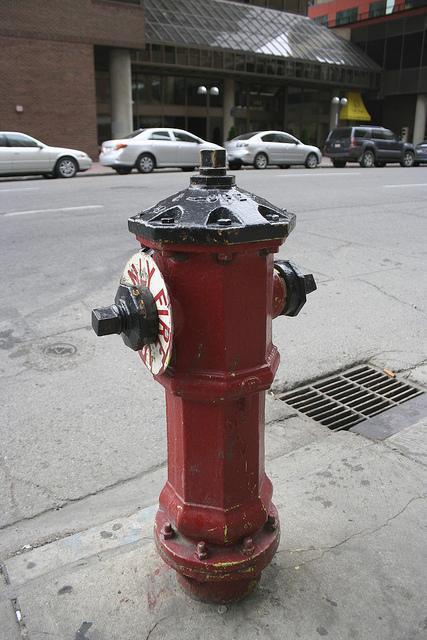What profession utilizes the red item in the foreground?
Select the correct answer and articulate reasoning with the following format: 'Answer: answer
Rationale: rationale.'
Options: Fire fighter, baker, butcher, drill sergeant. Answer: fire fighter.
Rationale: Hydrants give water which fire fighters use. What is the safety device in the foreground used to help defeat?
Select the accurate response from the four choices given to answer the question.
Options: Getaway cars, paper cuts, fires, vulture infestation. Fires. 